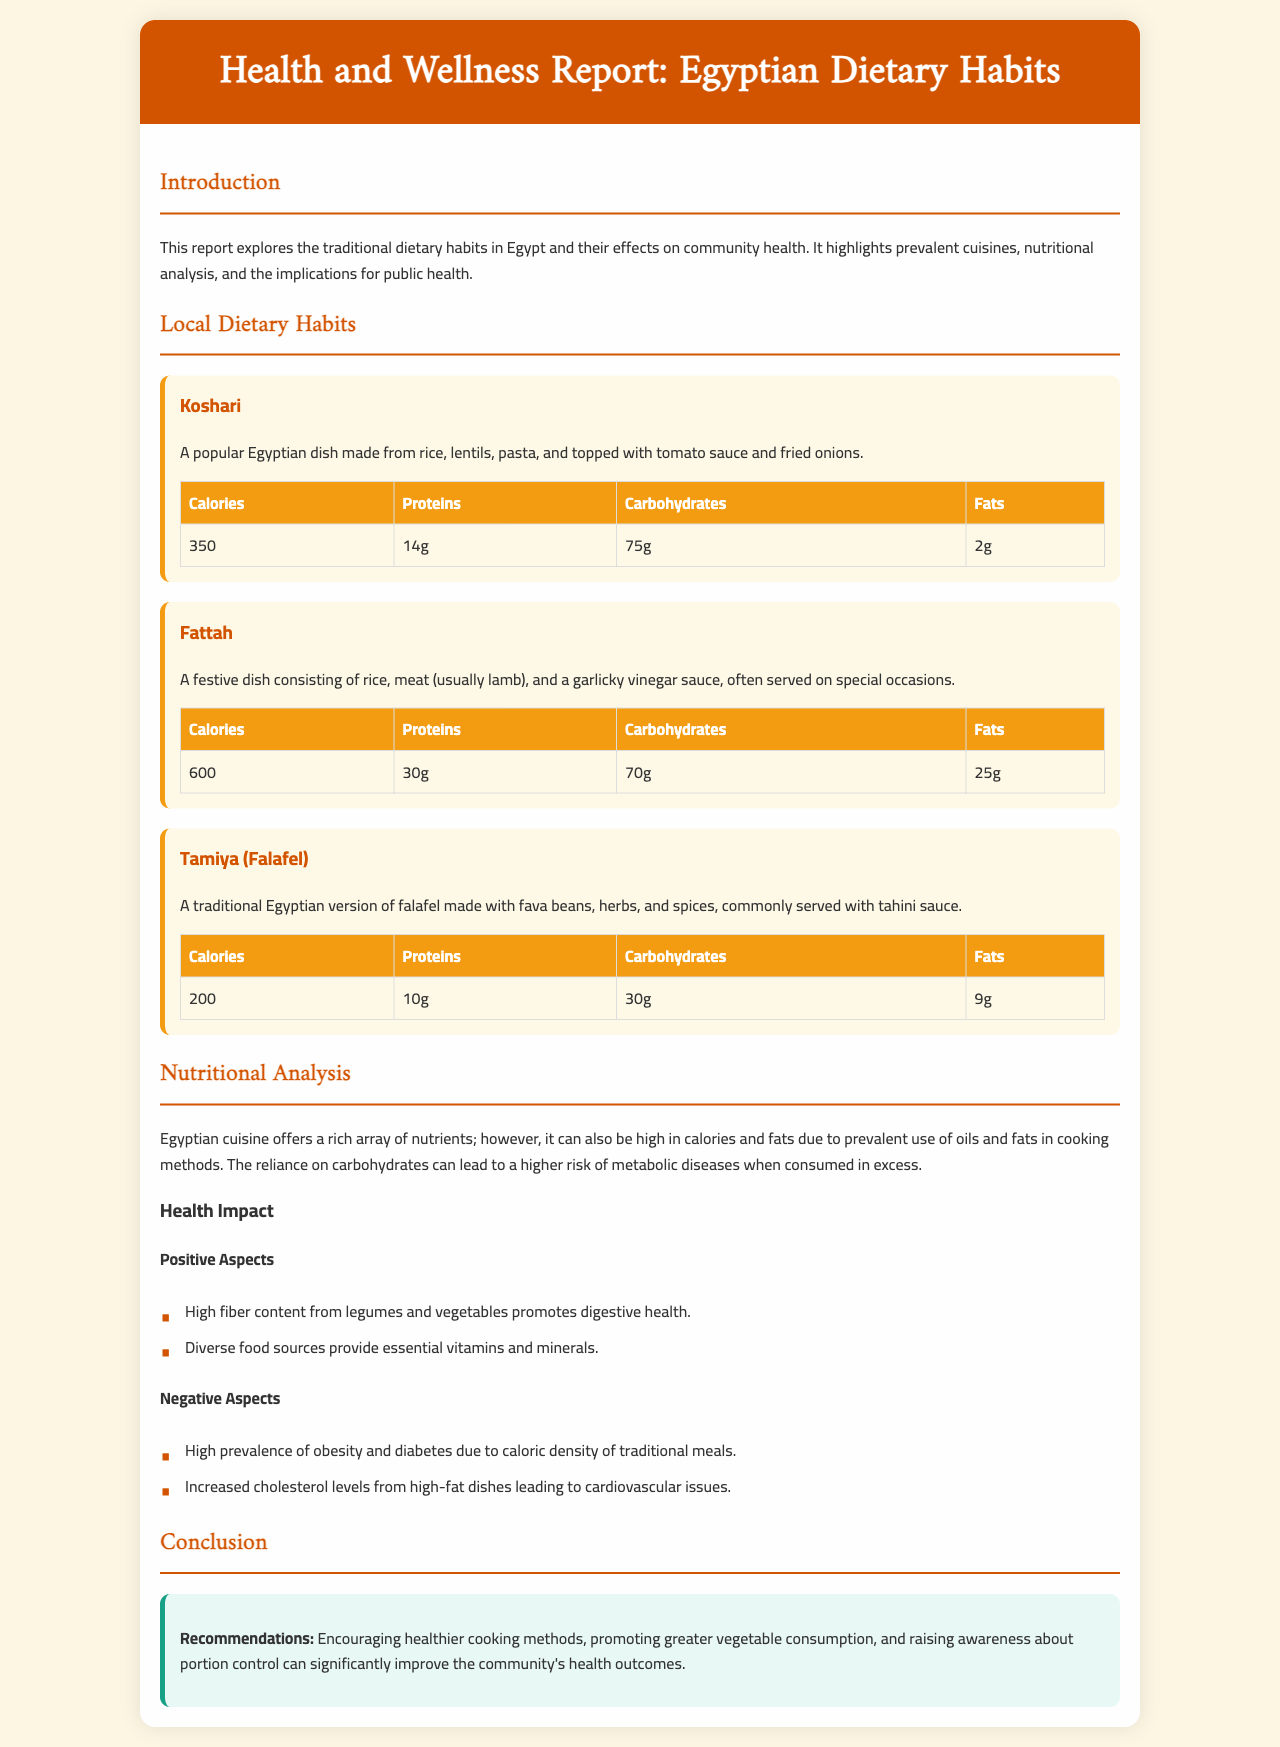What is the name of the popular Egyptian dish made from rice, lentils, and pasta? The document states that Koshari is a popular Egyptian dish made from rice, lentils, pasta, and topped with tomato sauce and fried onions.
Answer: Koshari How many grams of protein does Koshari contain? According to the nutritional table provided for Koshari, it contains 14 grams of protein.
Answer: 14g What is the calorie count for the dish Fattah? The document lists the calorie count for Fattah as 600 calories in its nutritional table.
Answer: 600 What are two positive health aspects mentioned in the report? The report lists "High fiber content from legumes and vegetables promotes digestive health" and "Diverse food sources provide essential vitamins and minerals" as positive health aspects.
Answer: High fiber content, Diverse food sources What type of beans are used in Tamiya? The document specifies that Tamiya, or falafel, is made with fava beans.
Answer: Fava beans What is one recommendation provided in the report to improve community health? The report recommends "Encouraging healthier cooking methods" as one of the ways to improve community health outcomes.
Answer: Encouraging healthier cooking methods What is the primary concern regarding the caloric density of traditional meals? The document mentions the concern about "High prevalence of obesity and diabetes due to caloric density of traditional meals."
Answer: Obesity and diabetes Which cuisine listed is typically served on special occasions? The report states that Fattah is a festive dish often served on special occasions.
Answer: Fattah What is the dominant cooking issue mentioned related to Egyptian dietary habits? The report indicates that the reliance on carbohydrates can lead to a higher risk of metabolic diseases when consumed in excess.
Answer: Reliance on carbohydrates 